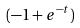<formula> <loc_0><loc_0><loc_500><loc_500>( - 1 + e ^ { - t } )</formula> 